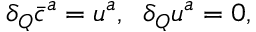Convert formula to latex. <formula><loc_0><loc_0><loc_500><loc_500>\delta _ { Q } \bar { c } ^ { a } = u ^ { a } , \, \delta _ { Q } u ^ { a } = 0 ,</formula> 